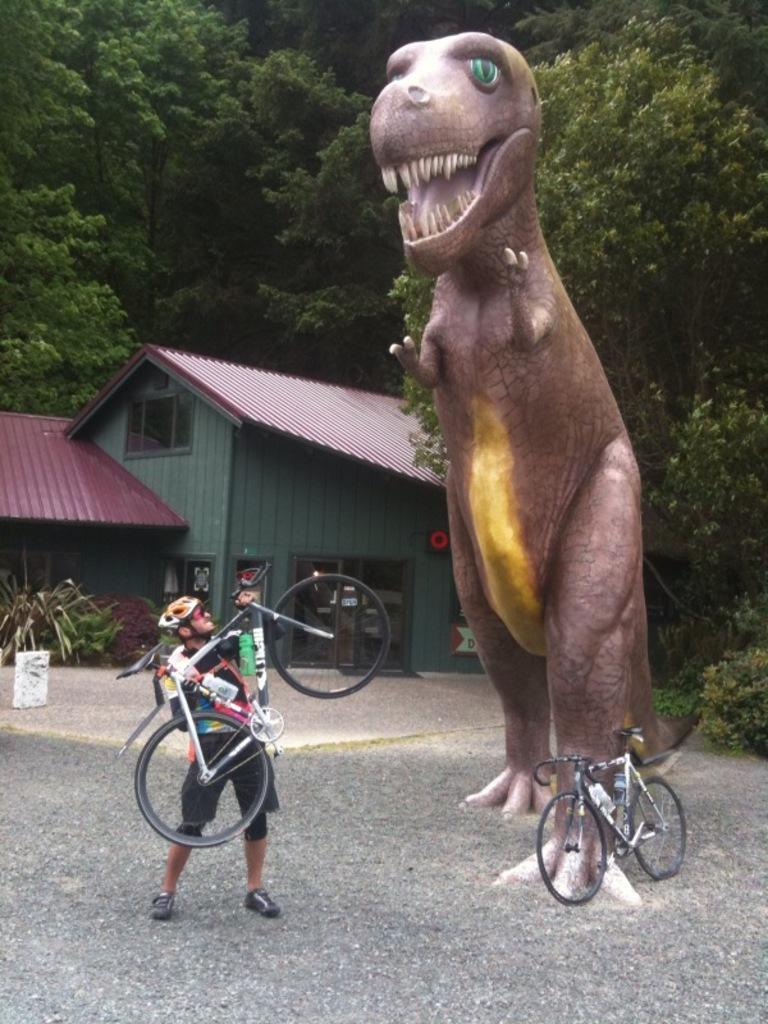What is the main subject in the image? There is a statue in the image. What is the person in the image doing? The person is holding a bicycle in the image. What type of natural elements can be seen in the image? There are trees and plants in the image. What architectural features are present in the image? There are windows and a house in the image. What is the additional transportation object in the image? There is a bicycle on the ground in the image. What type of slave is depicted in the image? There is no depiction of a slave in the image; it features a statue, a person holding a bicycle, trees, plants, windows, a house, and a bicycle on the ground. What sound can be heard coming from the statue in the image? The image does not depict any sound or audio; it is a still image. 